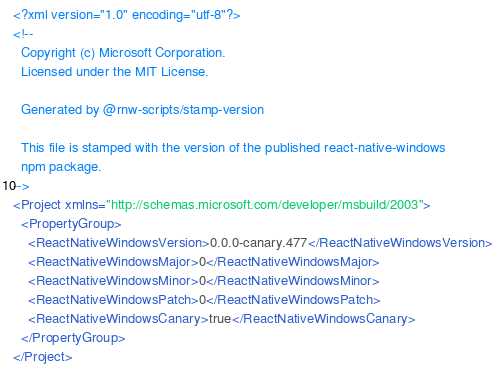<code> <loc_0><loc_0><loc_500><loc_500><_XML_><?xml version="1.0" encoding="utf-8"?>
<!-- 
  Copyright (c) Microsoft Corporation.
  Licensed under the MIT License.

  Generated by @rnw-scripts/stamp-version

  This file is stamped with the version of the published react-native-windows
  npm package.
-->
<Project xmlns="http://schemas.microsoft.com/developer/msbuild/2003">
  <PropertyGroup>
    <ReactNativeWindowsVersion>0.0.0-canary.477</ReactNativeWindowsVersion>
    <ReactNativeWindowsMajor>0</ReactNativeWindowsMajor>
    <ReactNativeWindowsMinor>0</ReactNativeWindowsMinor>
    <ReactNativeWindowsPatch>0</ReactNativeWindowsPatch>
    <ReactNativeWindowsCanary>true</ReactNativeWindowsCanary>
  </PropertyGroup>
</Project></code> 